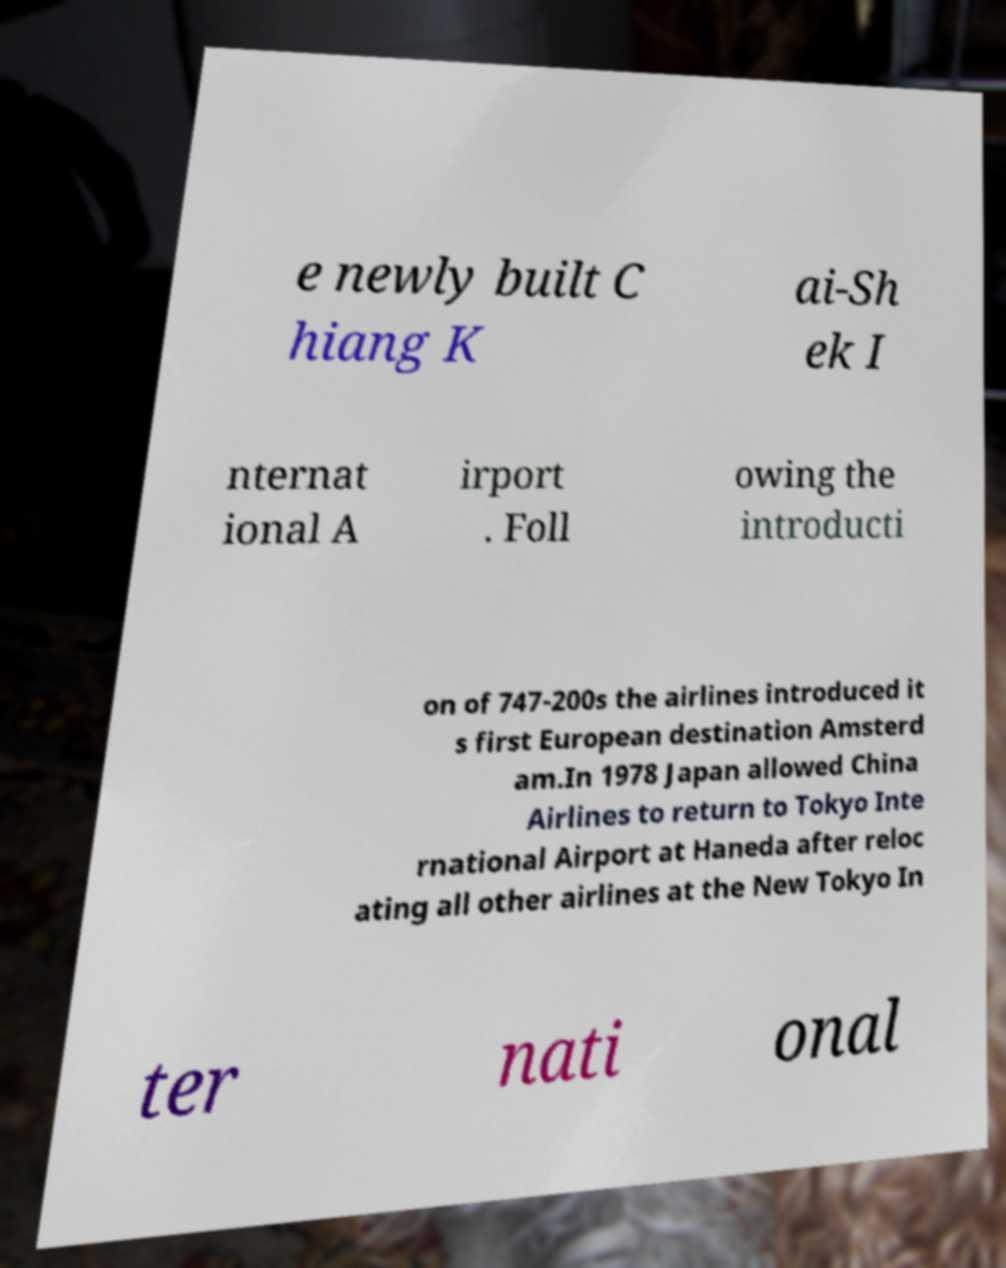Could you extract and type out the text from this image? e newly built C hiang K ai-Sh ek I nternat ional A irport . Foll owing the introducti on of 747-200s the airlines introduced it s first European destination Amsterd am.In 1978 Japan allowed China Airlines to return to Tokyo Inte rnational Airport at Haneda after reloc ating all other airlines at the New Tokyo In ter nati onal 